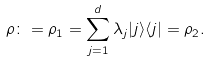Convert formula to latex. <formula><loc_0><loc_0><loc_500><loc_500>\rho \colon = \rho _ { 1 } = \sum _ { j = 1 } ^ { d } \lambda _ { j } | j \rangle \langle j | = \rho _ { 2 } .</formula> 